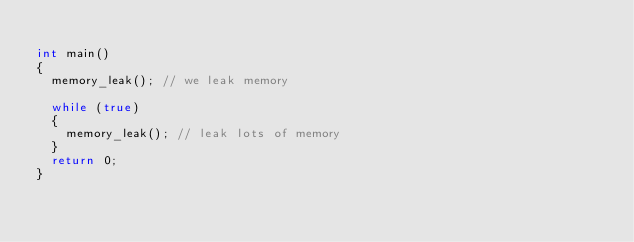Convert code to text. <code><loc_0><loc_0><loc_500><loc_500><_C++_>
int main() 
{
	memory_leak(); // we leak memory

	while (true)
	{
		memory_leak(); // leak lots of memory
	}
	return 0;
}</code> 